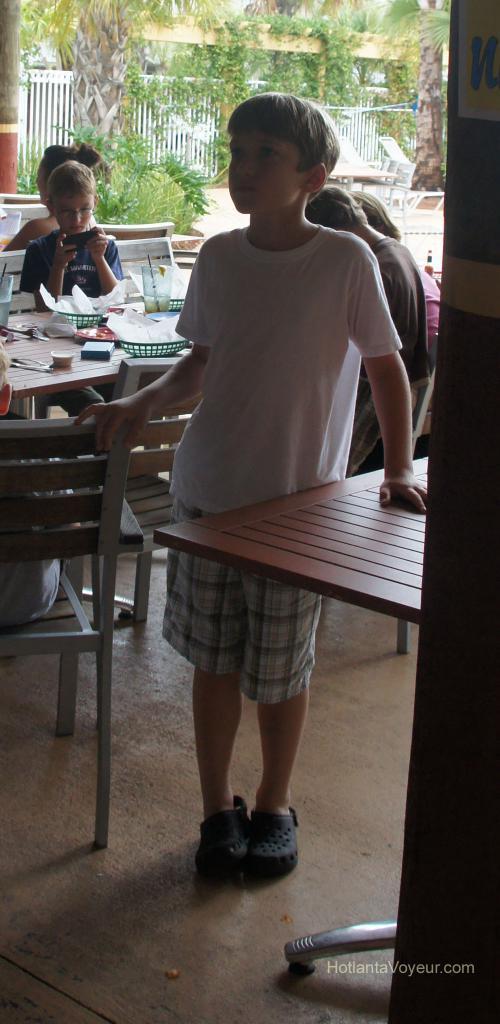Describe this image in one or two sentences. In this picture we can see one boy standing in between a chair and a table. On the background we can see a building, trees and a fence. We can see two persons sitting on chairs and also few persons sitting here. This boy is holding a mobile in his hand. On the table we can see spoons, tissues. 